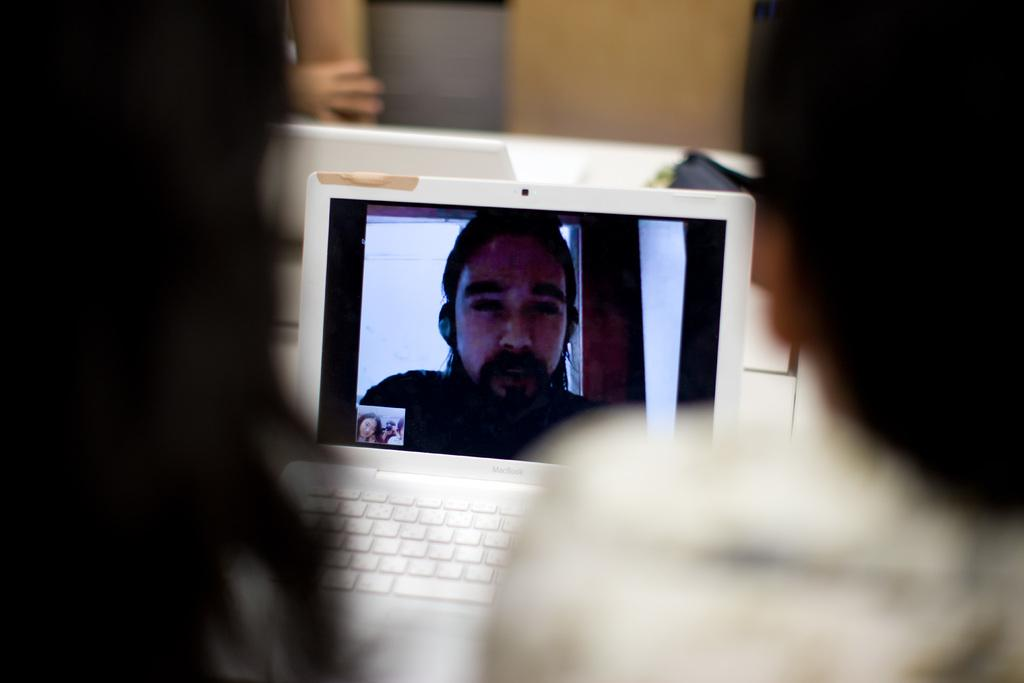How many people are present in the image? There are two persons in the image. What are the two persons doing in the image? The two persons are on a video call. Is there anyone else visible in the image? Yes, there is another person on a laptop in the image. Can you see any ducks balancing on a mountain in the image? No, there are no ducks or mountains present in the image. 